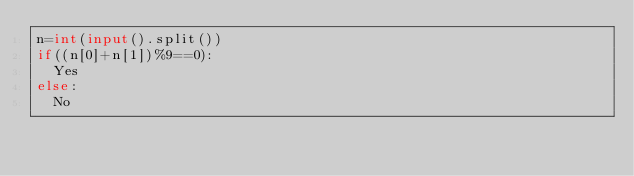<code> <loc_0><loc_0><loc_500><loc_500><_Python_>n=int(input().split())
if((n[0]+n[1])%9==0):
  Yes
else:
  No</code> 